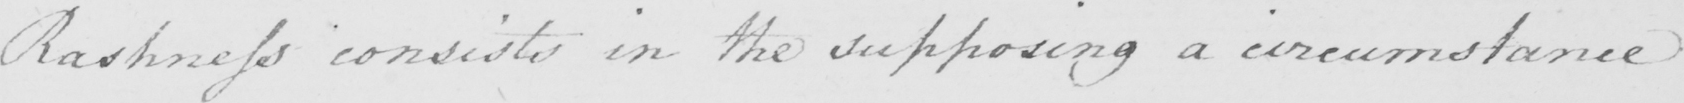Transcribe the text shown in this historical manuscript line. Rashness consists in the supposing a circumstance 